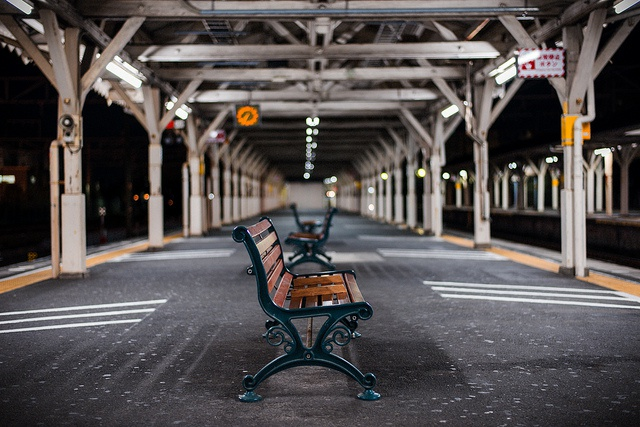Describe the objects in this image and their specific colors. I can see bench in black, gray, brown, and maroon tones, bench in black, gray, maroon, and darkgray tones, clock in black, orange, olive, and brown tones, and bench in black, gray, and blue tones in this image. 